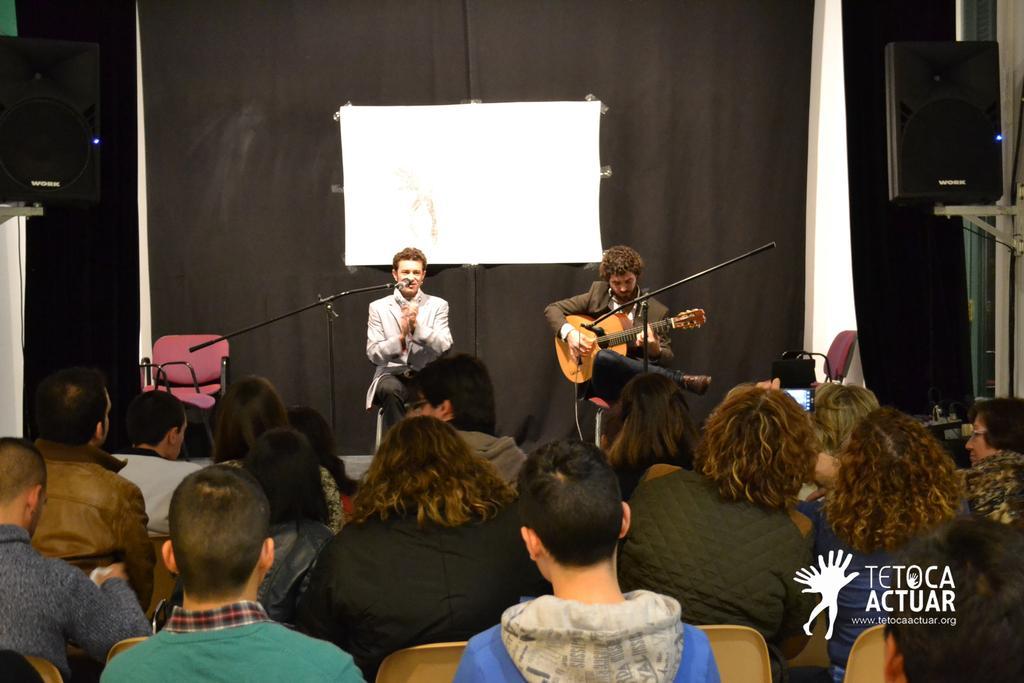Can you describe this image briefly? In this image there two people are sitting on the stage, one is playing guitar and one is singing and audience are sitting opposite to them. At the left there is a speaker and at the right there is a speaker, at the back there is a curtain. 